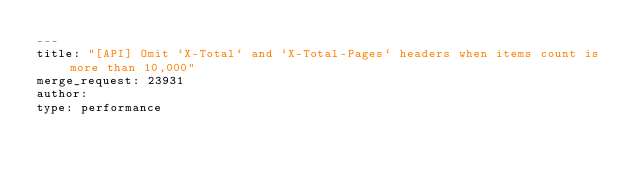Convert code to text. <code><loc_0><loc_0><loc_500><loc_500><_YAML_>---
title: "[API] Omit `X-Total` and `X-Total-Pages` headers when items count is more than 10,000"
merge_request: 23931
author:
type: performance
</code> 